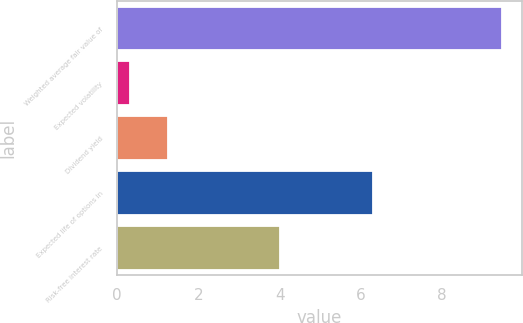Convert chart. <chart><loc_0><loc_0><loc_500><loc_500><bar_chart><fcel>Weighted average fair value of<fcel>Expected volatility<fcel>Dividend yield<fcel>Expected life of options in<fcel>Risk-free interest rate<nl><fcel>9.48<fcel>0.32<fcel>1.24<fcel>6.3<fcel>4<nl></chart> 